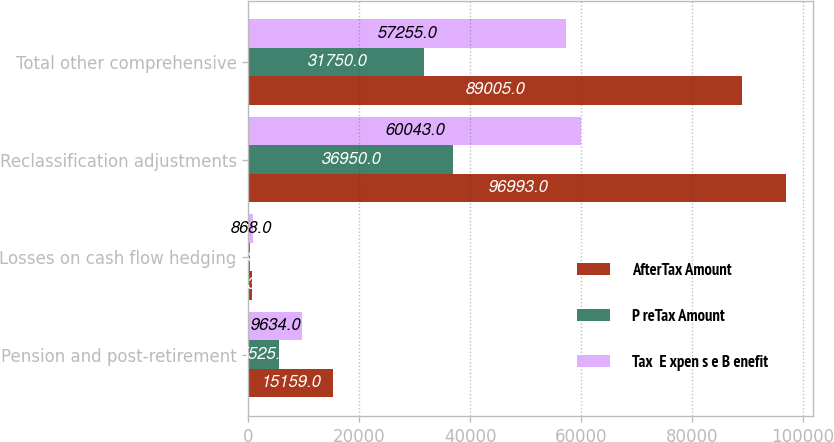Convert chart. <chart><loc_0><loc_0><loc_500><loc_500><stacked_bar_chart><ecel><fcel>Pension and post-retirement<fcel>Losses on cash flow hedging<fcel>Reclassification adjustments<fcel>Total other comprehensive<nl><fcel>AfterTax Amount<fcel>15159<fcel>543<fcel>96993<fcel>89005<nl><fcel>P reTax Amount<fcel>5525<fcel>325<fcel>36950<fcel>31750<nl><fcel>Tax  E xpen s e B enefit<fcel>9634<fcel>868<fcel>60043<fcel>57255<nl></chart> 